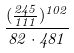Convert formula to latex. <formula><loc_0><loc_0><loc_500><loc_500>\frac { ( \frac { 2 4 5 } { 1 1 1 } ) ^ { 1 0 2 } } { 8 2 \cdot 4 8 1 }</formula> 